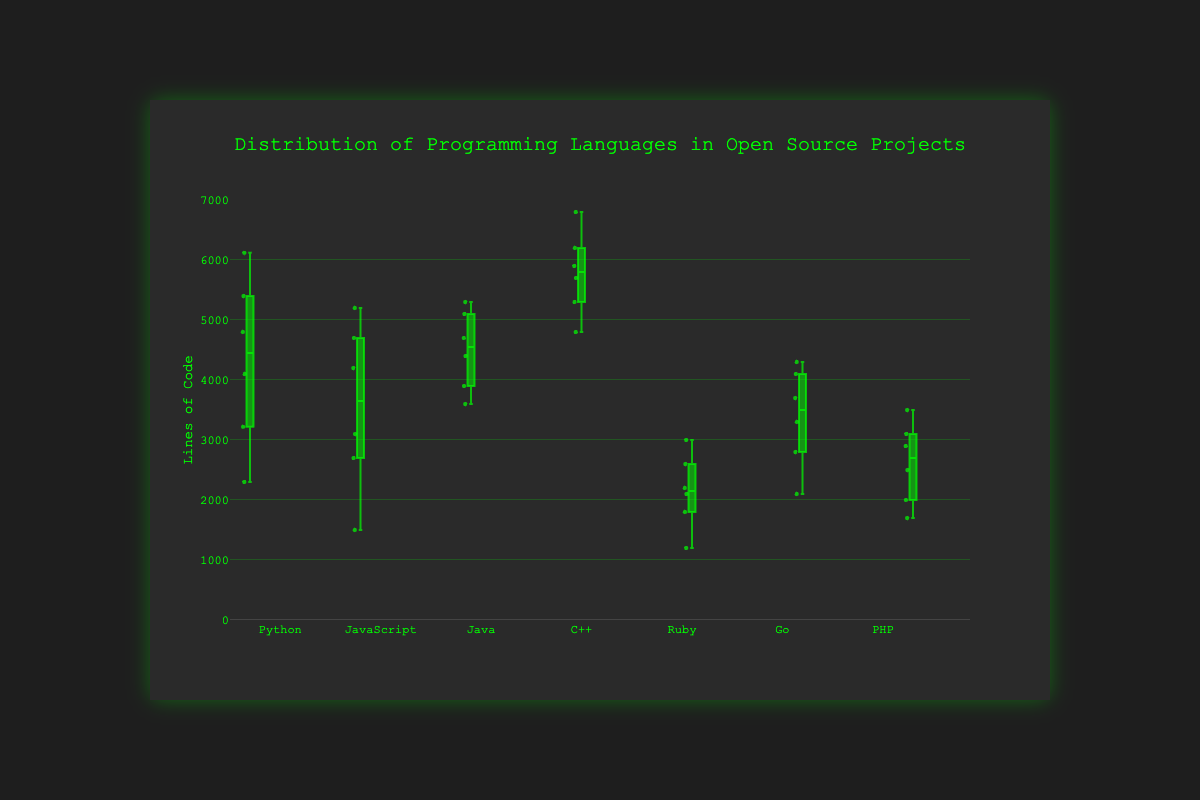What's the title of the figure? The title of the figure is displayed at the top and reads "Distribution of Programming Languages in Open Source Projects."
Answer: Distribution of Programming Languages in Open Source Projects What is the range of the y-axis? The range of the y-axis can be determined by looking at the minimum and maximum tick marks. The y-axis ranges from 0 to 7000.
Answer: 0 to 7000 Which programming language has the widest interquartile range (IQR)? The IQR is the difference between the first quartile (Q1) and the third quartile (Q3). Python has the widest IQR, as it spans from approximately 3200 to 5400 lines of code.
Answer: Python Which programming language has the smallest median number of lines of code? By looking at the line inside each box, Ruby has the smallest median number of lines of code, which is around 2100.
Answer: Ruby Between Python and JavaScript, which has a higher maximum number of lines of code and what is it? The maximum number of lines of code is indicated by the top whisker of the box plot. Python has a higher maximum with approximately 6120 lines, compared to JavaScript's maximum of about 5200 lines.
Answer: Python, 6120 What's the median number of lines of code for Java? The median is represented by the line inside the box. For Java, this line is around 4700 lines of code.
Answer: 4700 Compare the 3rd quartile (Q3) of PHP and Go. Which is higher and by how much? Q3 can be identified as the top edge of the box. For PHP, Q3 is around 3500; for Go, it is about 4100. Go's Q3 is higher by 4100 - 3500 = 600 lines.
Answer: Go, 600 lines Which language has the fewest outliers and how can you tell? The outliers are shown as individual points outside the whiskers. Java has no visible outliers, so it has the fewest outliers.
Answer: Java What is the range of lines of code for C++? The range is the difference between the maximum and minimum values. For C++, this range is from about 4800 to 6800, so 6800 - 4800 = 2000.
Answer: 2000 Which language data set looks the most symmetric and why? Symmetry can be observed if the median splits the box into two equal halves and the whiskers are of equal length. JavaScript appears the most symmetric as the box is balanced and the whiskers are of similar length.
Answer: JavaScript 